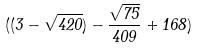<formula> <loc_0><loc_0><loc_500><loc_500>( ( 3 - \sqrt { 4 2 0 } ) - \frac { \sqrt { 7 5 } } { 4 0 9 } + 1 6 8 )</formula> 